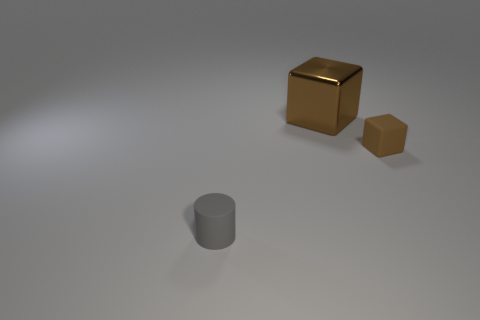Is there anything else of the same color as the matte block?
Offer a very short reply. Yes. Is the material of the tiny gray thing the same as the cube in front of the large brown metal cube?
Offer a terse response. Yes. What is the shape of the tiny matte thing that is right of the tiny matte object that is to the left of the large brown metal object?
Give a very brief answer. Cube. There is a object that is on the left side of the small brown rubber cube and in front of the big brown thing; what shape is it?
Your answer should be very brief. Cylinder. How many things are either shiny cubes or things in front of the brown metallic thing?
Offer a very short reply. 3. What is the material of the other small object that is the same shape as the brown metallic thing?
Provide a succinct answer. Rubber. Is there anything else that is the same material as the gray cylinder?
Your response must be concise. Yes. There is a object that is both right of the gray rubber cylinder and in front of the metallic block; what material is it made of?
Provide a short and direct response. Rubber. How many other brown things have the same shape as the tiny brown rubber object?
Offer a very short reply. 1. There is a tiny thing that is in front of the small object that is to the right of the gray matte cylinder; what is its color?
Your answer should be very brief. Gray. 